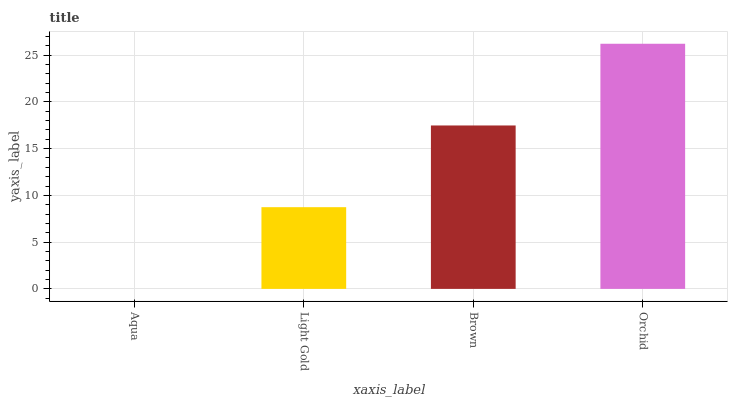Is Aqua the minimum?
Answer yes or no. Yes. Is Orchid the maximum?
Answer yes or no. Yes. Is Light Gold the minimum?
Answer yes or no. No. Is Light Gold the maximum?
Answer yes or no. No. Is Light Gold greater than Aqua?
Answer yes or no. Yes. Is Aqua less than Light Gold?
Answer yes or no. Yes. Is Aqua greater than Light Gold?
Answer yes or no. No. Is Light Gold less than Aqua?
Answer yes or no. No. Is Brown the high median?
Answer yes or no. Yes. Is Light Gold the low median?
Answer yes or no. Yes. Is Orchid the high median?
Answer yes or no. No. Is Orchid the low median?
Answer yes or no. No. 